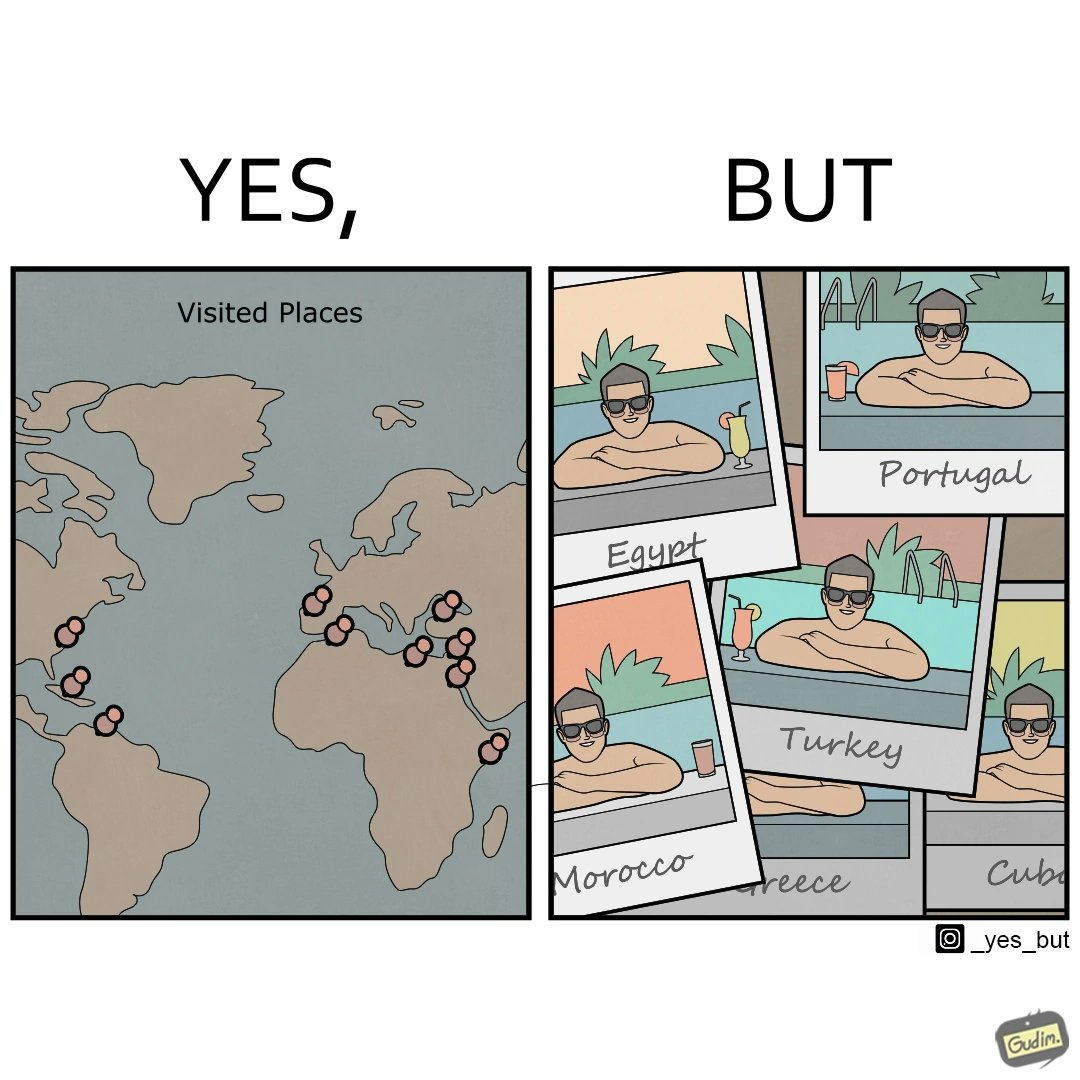Explain why this image is satirical. The image is satirical because while the man has visited all the place marked on the map, he only seems to have swam in pools in all these differnt countries and has not actually seen these places. 